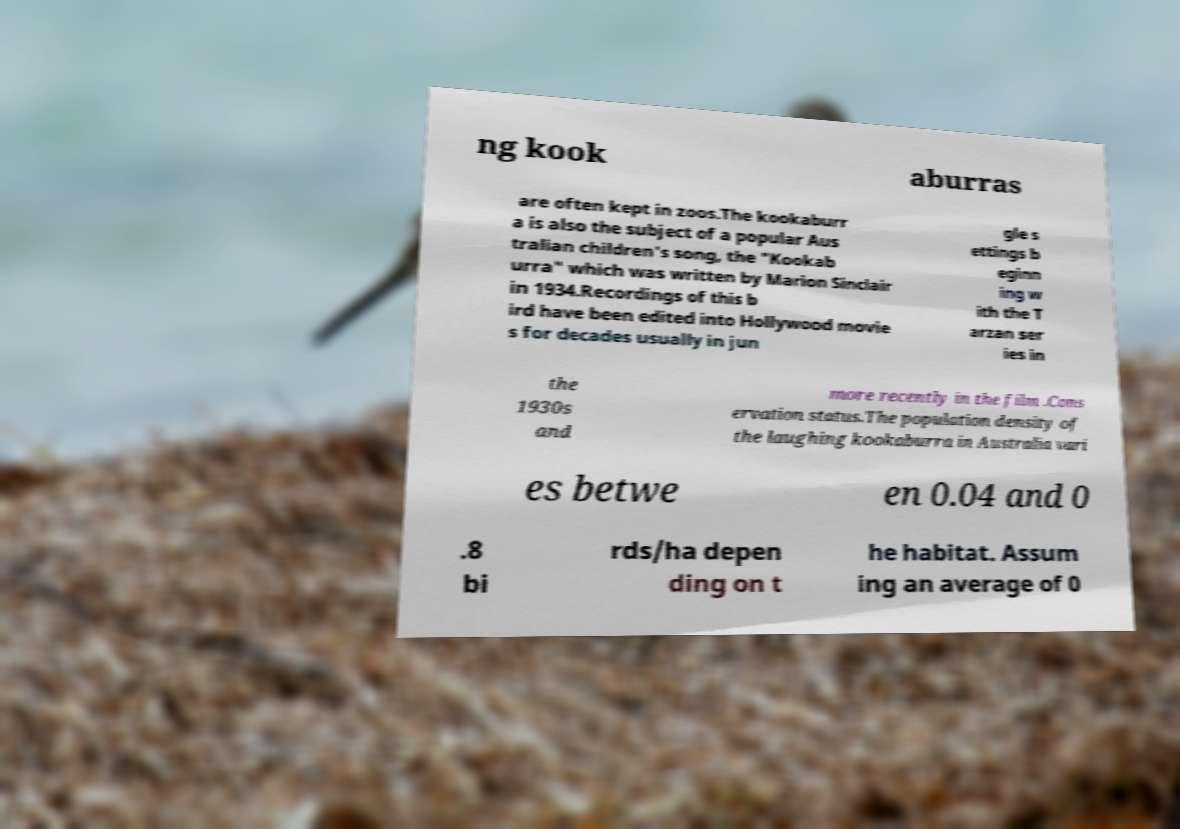Please read and relay the text visible in this image. What does it say? ng kook aburras are often kept in zoos.The kookaburr a is also the subject of a popular Aus tralian children's song, the "Kookab urra" which was written by Marion Sinclair in 1934.Recordings of this b ird have been edited into Hollywood movie s for decades usually in jun gle s ettings b eginn ing w ith the T arzan ser ies in the 1930s and more recently in the film .Cons ervation status.The population density of the laughing kookaburra in Australia vari es betwe en 0.04 and 0 .8 bi rds/ha depen ding on t he habitat. Assum ing an average of 0 